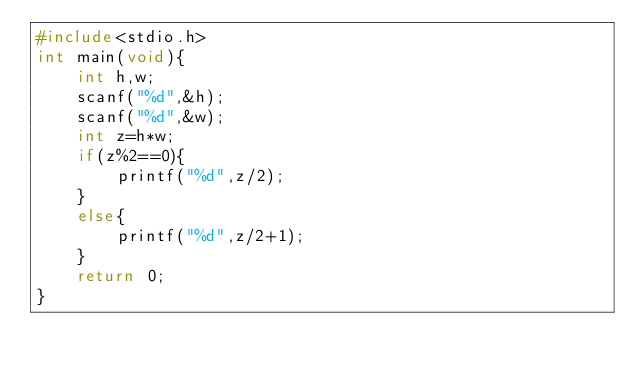Convert code to text. <code><loc_0><loc_0><loc_500><loc_500><_C_>#include<stdio.h>
int main(void){
    int h,w;
    scanf("%d",&h);
    scanf("%d",&w);
    int z=h*w;
    if(z%2==0){
        printf("%d",z/2);
    }
    else{
        printf("%d",z/2+1);
    }
    return 0;
}</code> 